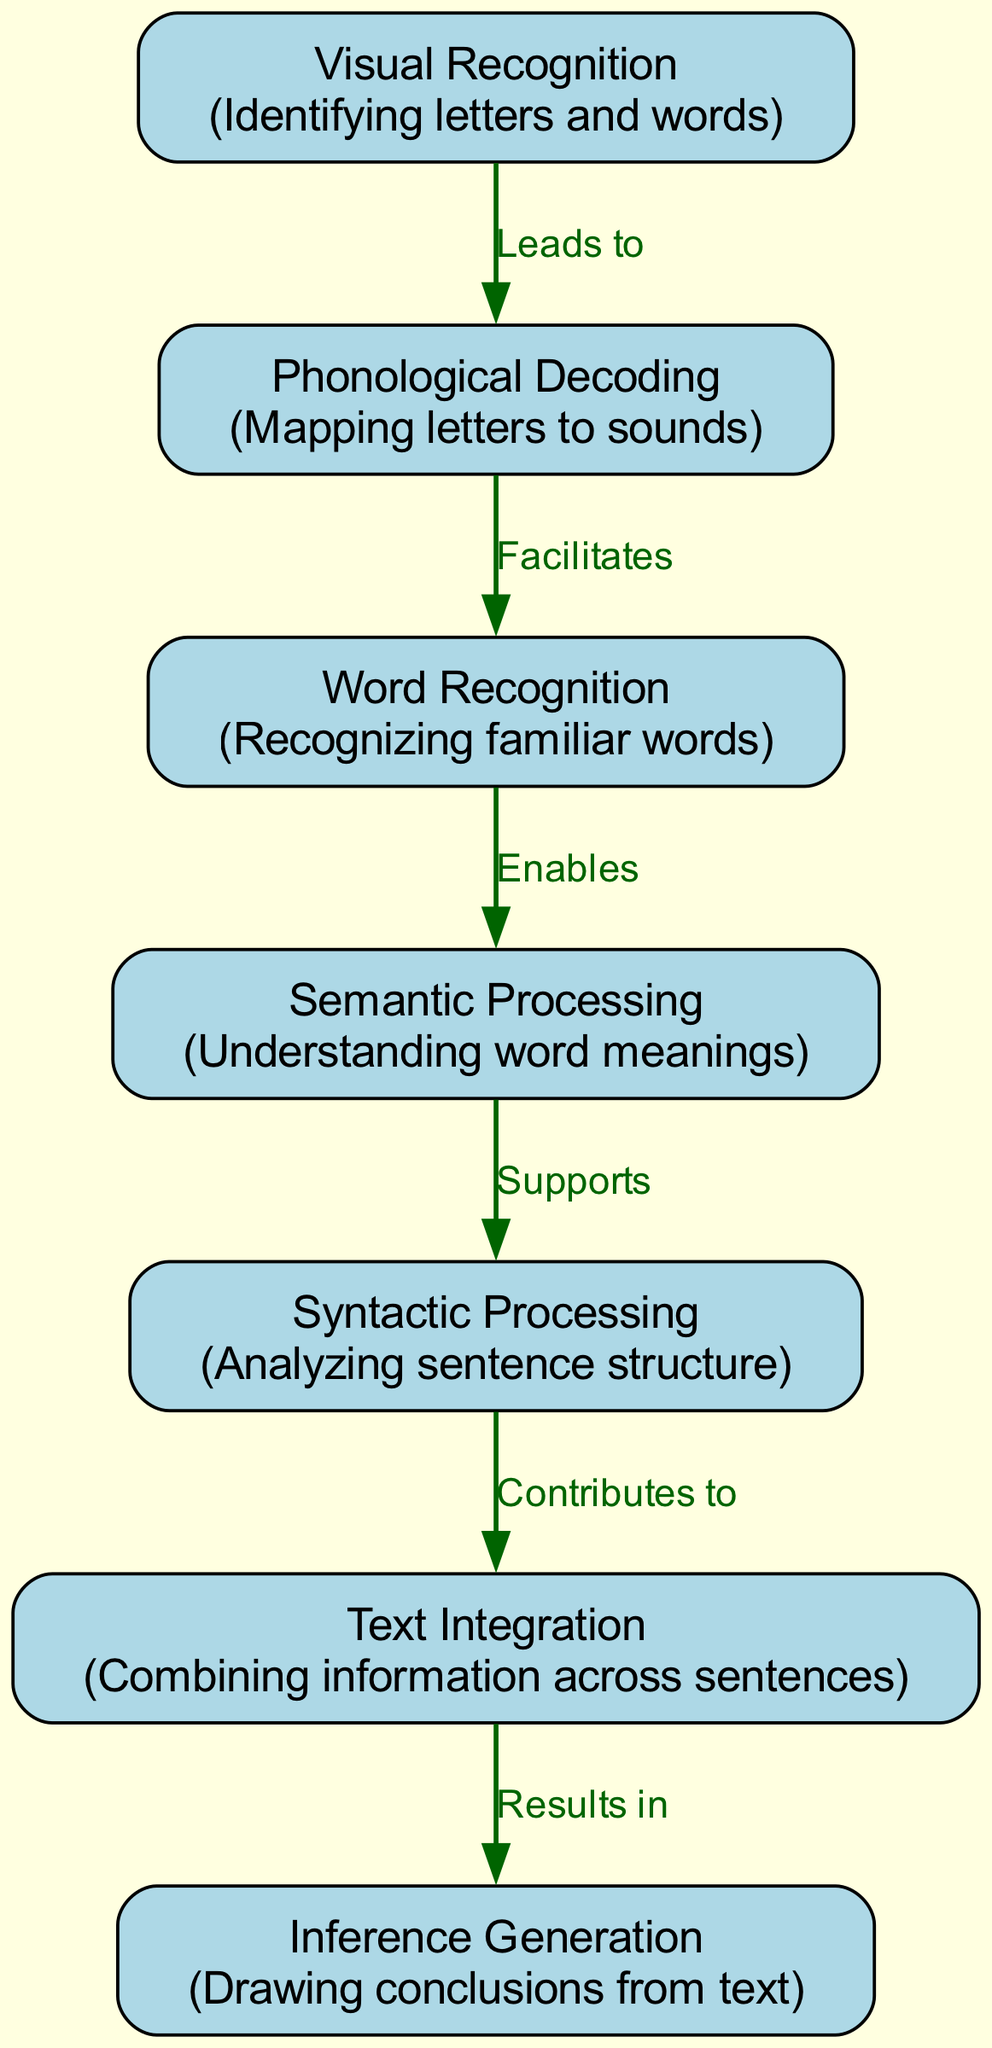What is the first stage in reading comprehension? The diagram starts with the node "Visual Recognition" which identifies letters and words, representing the first stage of reading comprehension.
Answer: Visual Recognition How many total nodes are in the diagram? The diagram lists a total of 7 nodes, which represent different stages of reading comprehension.
Answer: 7 What is the relationship between Phonological Decoding and Word Recognition? The diagram shows that "Phonological Decoding" facilitates "Word Recognition," indicating that phonological decoding helps in recognizing words.
Answer: Facilitates Which node supports Syntactic Processing? The diagram indicates that "Semantic Processing" supports "Syntactic Processing," which means understanding word meanings aids in analyzing sentence structure.
Answer: Semantic Processing What is the final stage of reading comprehension in this model? According to the diagram, "Inference Generation" is the final stage since it follows after "Text Integration."
Answer: Inference Generation How does Text Integration relate to Inference Generation? The diagram illustrates that "Text Integration" results in "Inference Generation," meaning combining information leads to drawing conclusions from the text.
Answer: Results in Which node focuses on understanding word meanings? The node labeled "Semantic Processing" in the diagram is specifically dedicated to understanding the meanings of words.
Answer: Semantic Processing What stage comes after Word Recognition? Based on the flow of the diagram, "Semantic Processing" comes after "Word Recognition," showing the order of stages in reading comprehension.
Answer: Semantic Processing What support does Syntactic Processing provide? The diagram states that "Syntactic Processing" contributes to "Text Integration," indicating that analyzing sentence structure aids in combining information.
Answer: Contributes to 